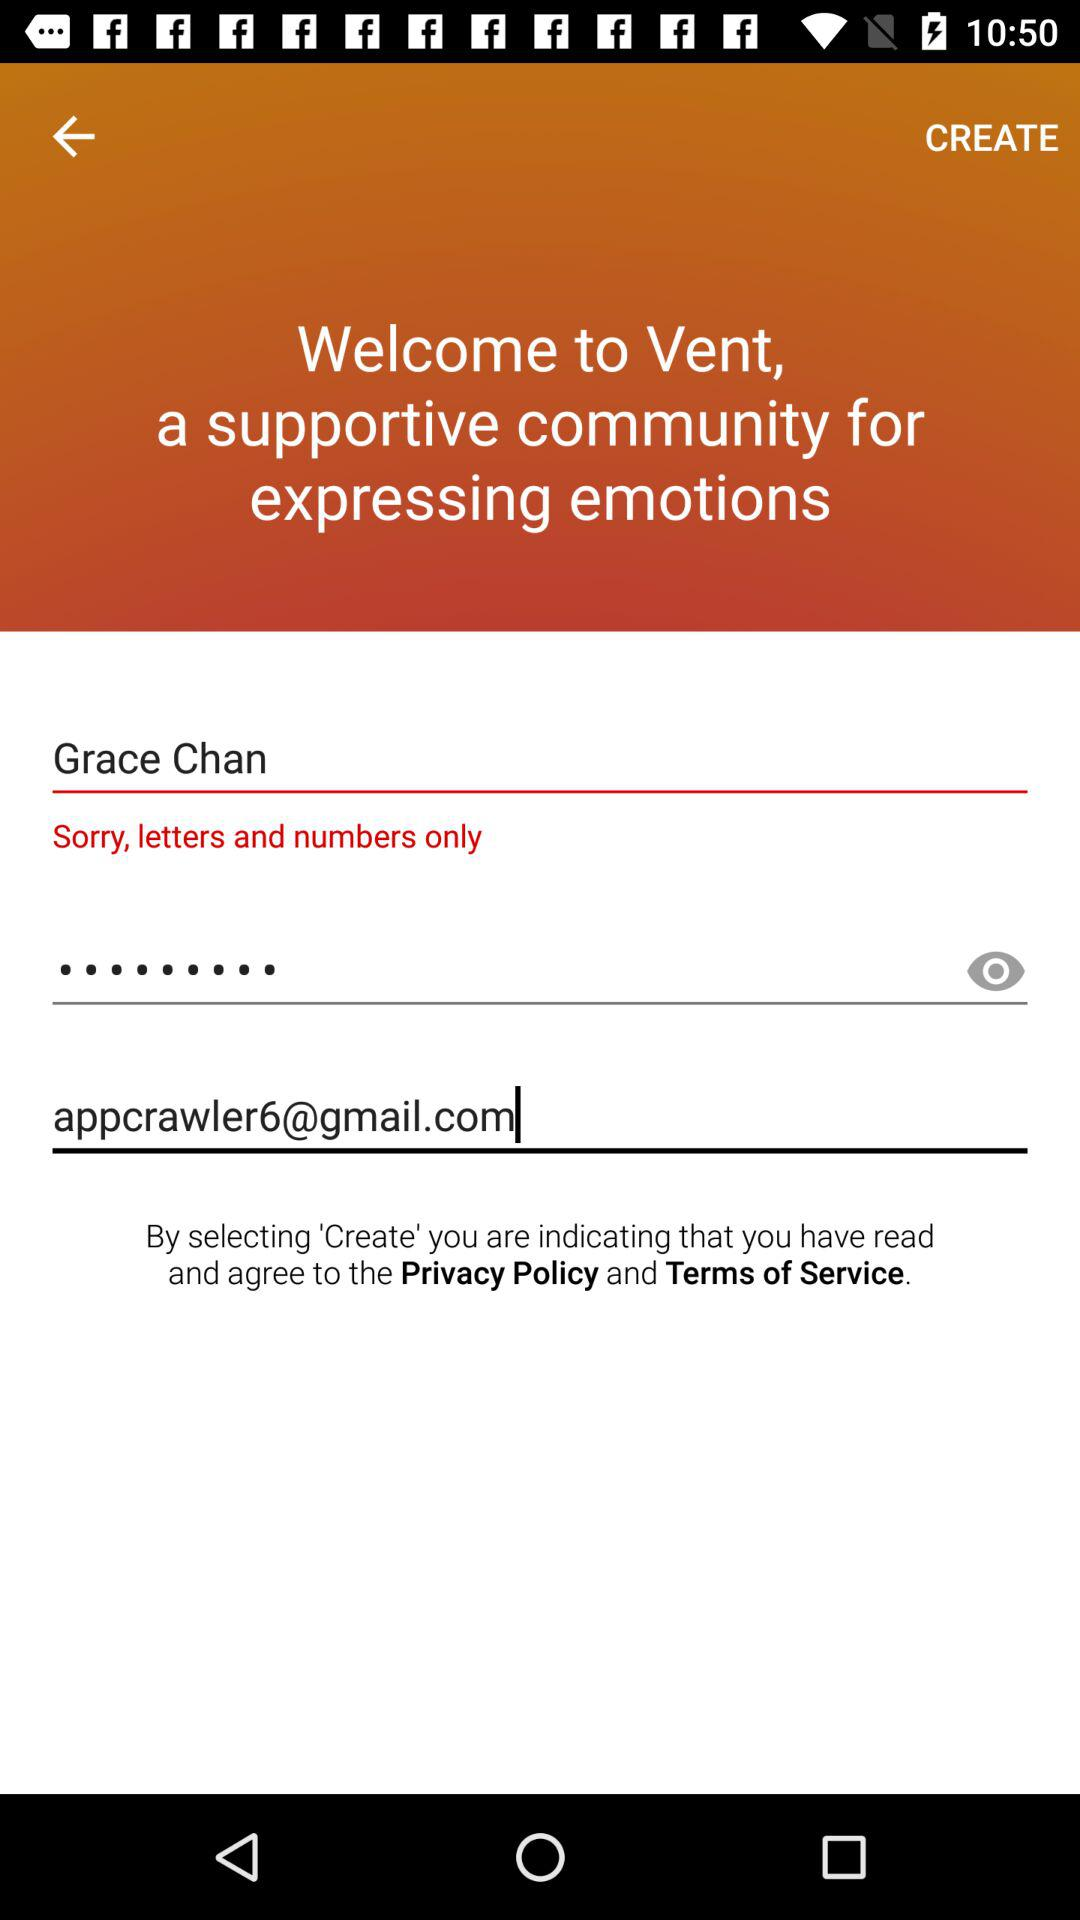What is the email address? The email address is appcrawler6@gmail.com. 